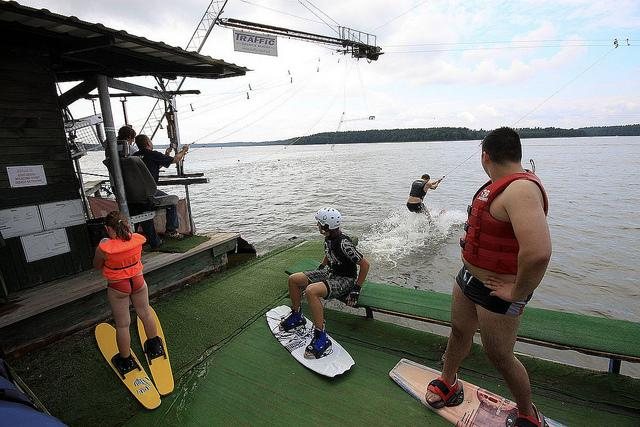What is the man wearing in red? Please explain your reasoning. lifejacket. The red vest this man wears is a flotation device. 